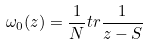Convert formula to latex. <formula><loc_0><loc_0><loc_500><loc_500>\omega _ { 0 } ( z ) = \frac { 1 } { N } t r \frac { 1 } { z - S }</formula> 